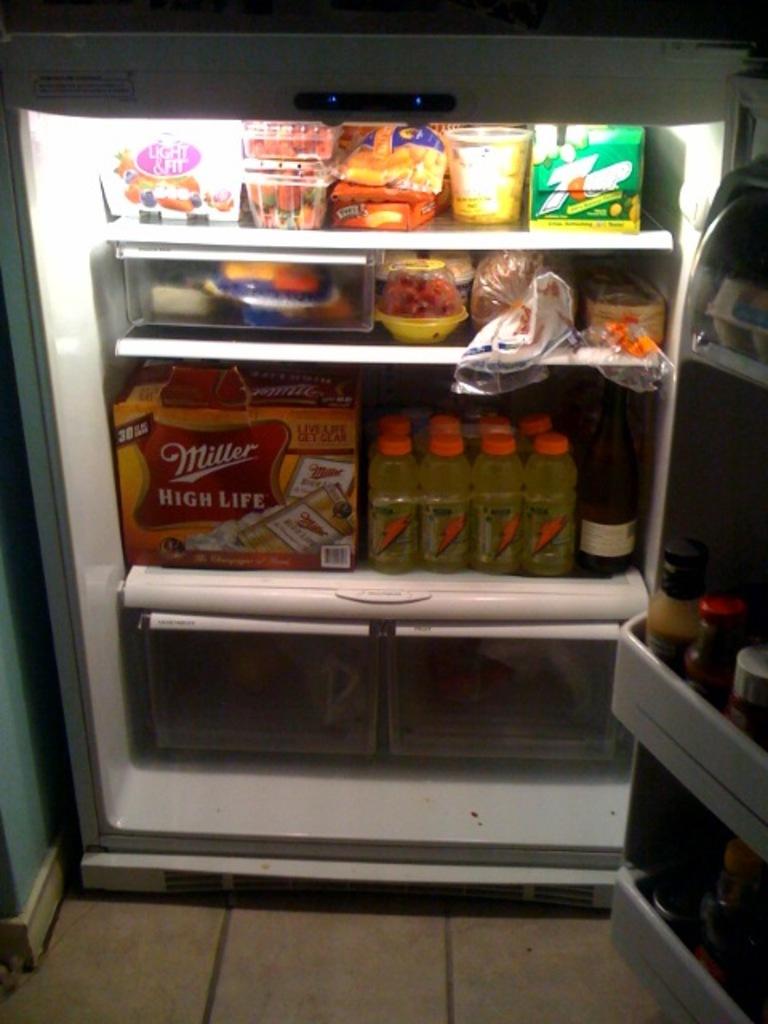What brand of beer is in the case on the lower shelf?
Offer a very short reply. Miller. What brand of soda is in the green box?
Your answer should be very brief. 7up. 